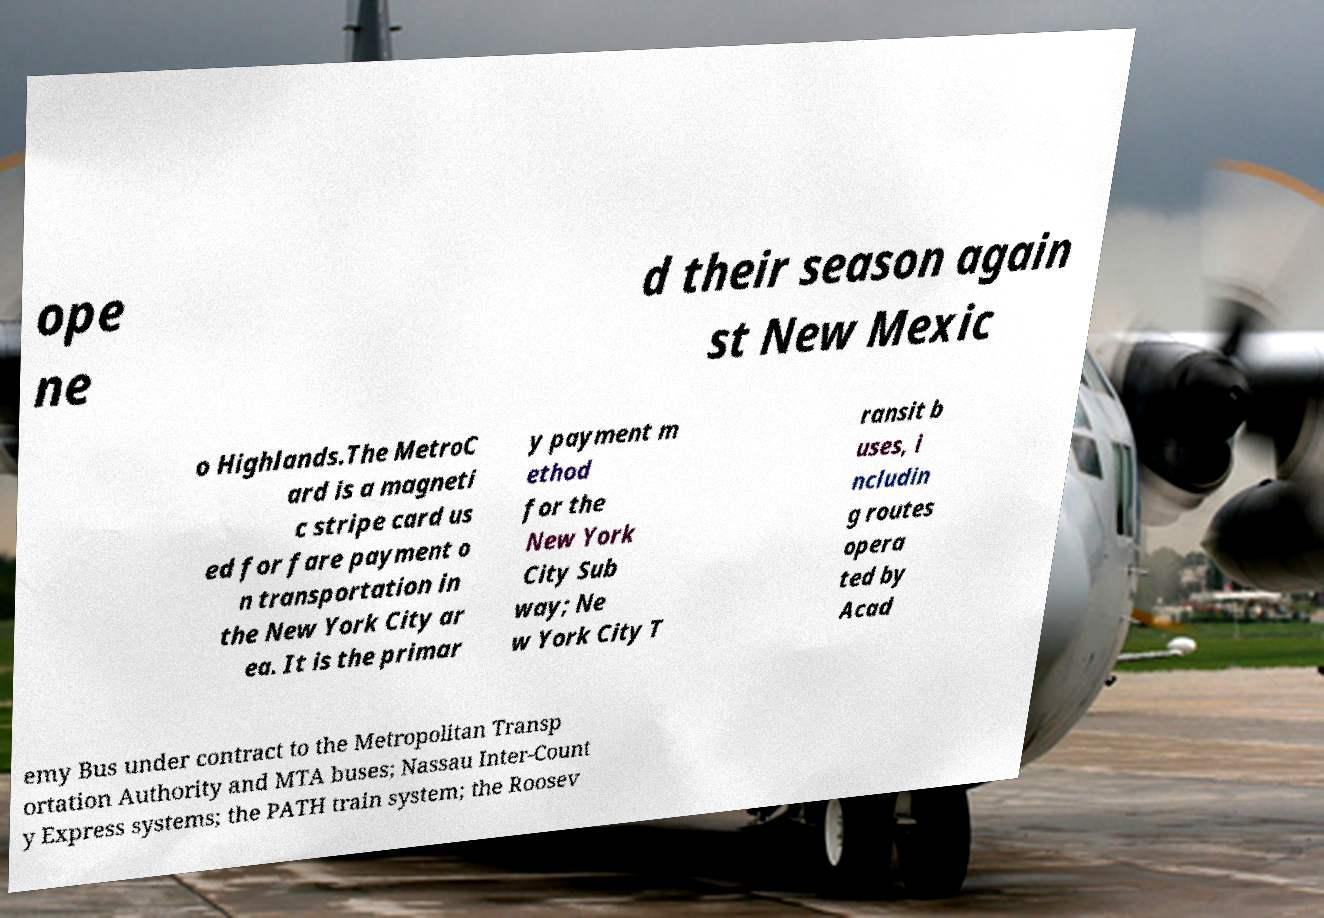Can you read and provide the text displayed in the image?This photo seems to have some interesting text. Can you extract and type it out for me? ope ne d their season again st New Mexic o Highlands.The MetroC ard is a magneti c stripe card us ed for fare payment o n transportation in the New York City ar ea. It is the primar y payment m ethod for the New York City Sub way; Ne w York City T ransit b uses, i ncludin g routes opera ted by Acad emy Bus under contract to the Metropolitan Transp ortation Authority and MTA buses; Nassau Inter-Count y Express systems; the PATH train system; the Roosev 